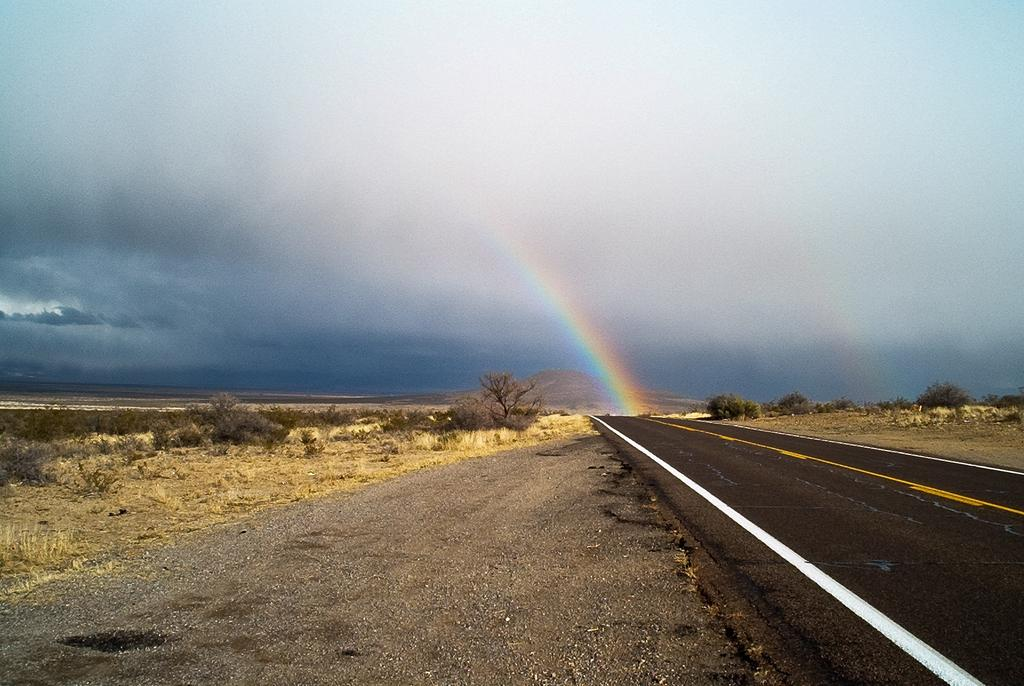What is the main feature of the image? There is a road in the image. What other elements can be seen in the image? There are trees, the sky, clouds, a rainbow, and a hill in the image. Can you describe the sky in the image? The sky is visible in the background of the image, and it contains clouds. What natural phenomenon is present in the image? There is a rainbow in the image. Where is the cannon located in the image? There is no cannon present in the image. What type of coil is used to create the rainbow in the image? The image does not show the process of creating the rainbow, so it is not possible to determine what type of coil might be used. 